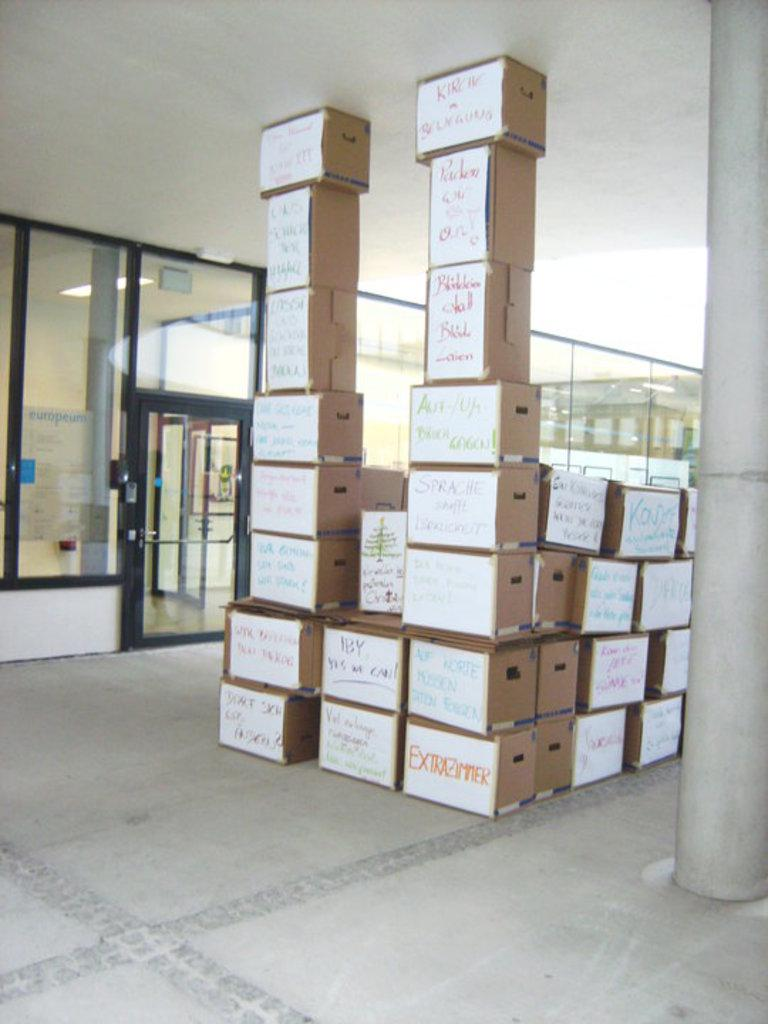<image>
Render a clear and concise summary of the photo. Tall stacks of cardboard boxes the bottom right one says Extrazimmer. 